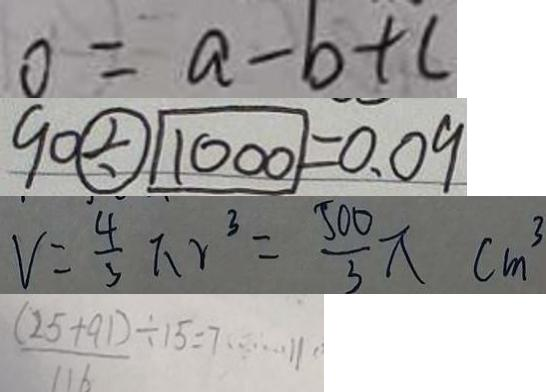<formula> <loc_0><loc_0><loc_500><loc_500>0 = a - b + c 
 9 0 \textcircled { \div } 1 0 0 0 = 0 . 0 9 
 v = \frac { 4 } { 3 } \pi r ^ { 3 } = \frac { 5 0 0 } { 3 } \pi c m ^ { 3 } 
 \frac { ( 2 5 + 9 1 ) } { 1 1 6 } \div 1 5 = 7 \cdots 1 1</formula> 